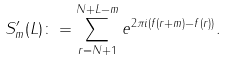<formula> <loc_0><loc_0><loc_500><loc_500>S _ { m } ^ { \prime } ( L ) \colon = \sum _ { r = N + 1 } ^ { N + L - m } e ^ { 2 \pi i ( f ( r + m ) - f ( r ) ) } .</formula> 